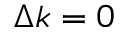<formula> <loc_0><loc_0><loc_500><loc_500>\Delta k = 0</formula> 